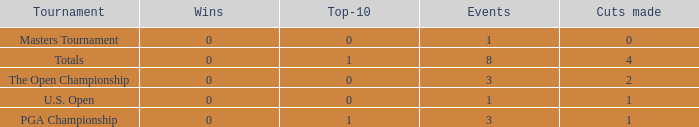For events with under 3 times played and fewer than 1 cut made, what is the total number of top-10 finishes? 1.0. 